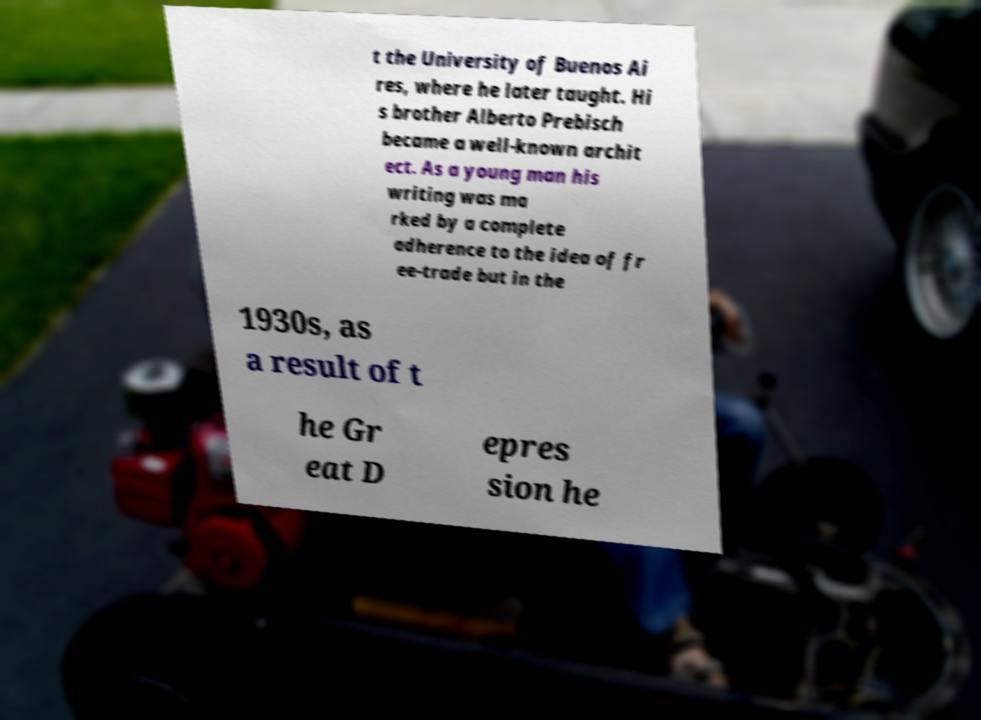Please read and relay the text visible in this image. What does it say? t the University of Buenos Ai res, where he later taught. Hi s brother Alberto Prebisch became a well-known archit ect. As a young man his writing was ma rked by a complete adherence to the idea of fr ee-trade but in the 1930s, as a result of t he Gr eat D epres sion he 